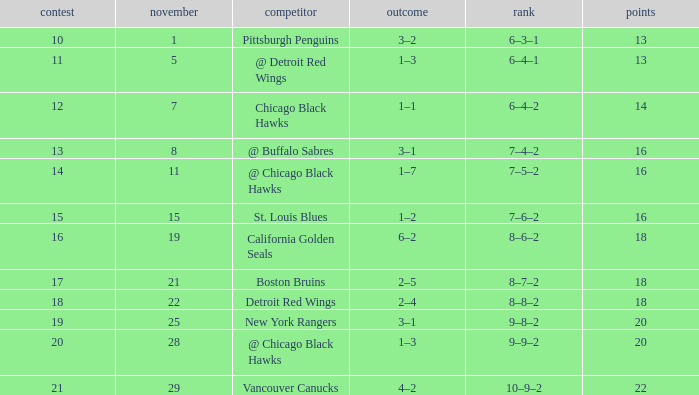What is the highest November that has a game less than 12, and @ detroit red wings as the opponent? 5.0. Could you help me parse every detail presented in this table? {'header': ['contest', 'november', 'competitor', 'outcome', 'rank', 'points'], 'rows': [['10', '1', 'Pittsburgh Penguins', '3–2', '6–3–1', '13'], ['11', '5', '@ Detroit Red Wings', '1–3', '6–4–1', '13'], ['12', '7', 'Chicago Black Hawks', '1–1', '6–4–2', '14'], ['13', '8', '@ Buffalo Sabres', '3–1', '7–4–2', '16'], ['14', '11', '@ Chicago Black Hawks', '1–7', '7–5–2', '16'], ['15', '15', 'St. Louis Blues', '1–2', '7–6–2', '16'], ['16', '19', 'California Golden Seals', '6–2', '8–6–2', '18'], ['17', '21', 'Boston Bruins', '2–5', '8–7–2', '18'], ['18', '22', 'Detroit Red Wings', '2–4', '8–8–2', '18'], ['19', '25', 'New York Rangers', '3–1', '9–8–2', '20'], ['20', '28', '@ Chicago Black Hawks', '1–3', '9–9–2', '20'], ['21', '29', 'Vancouver Canucks', '4–2', '10–9–2', '22']]} 